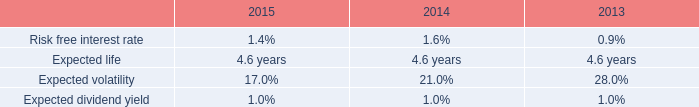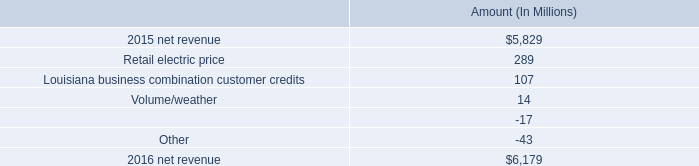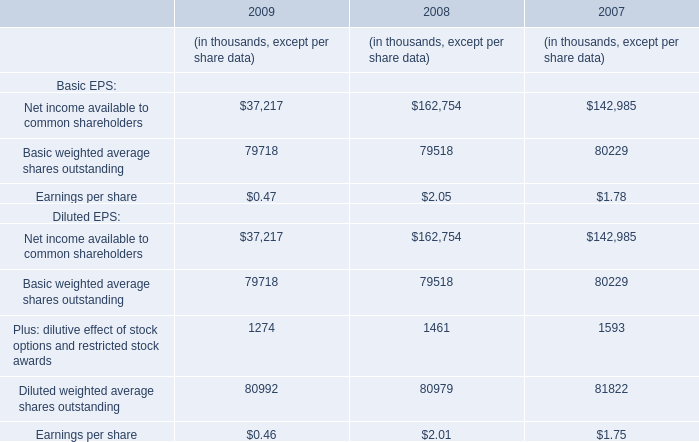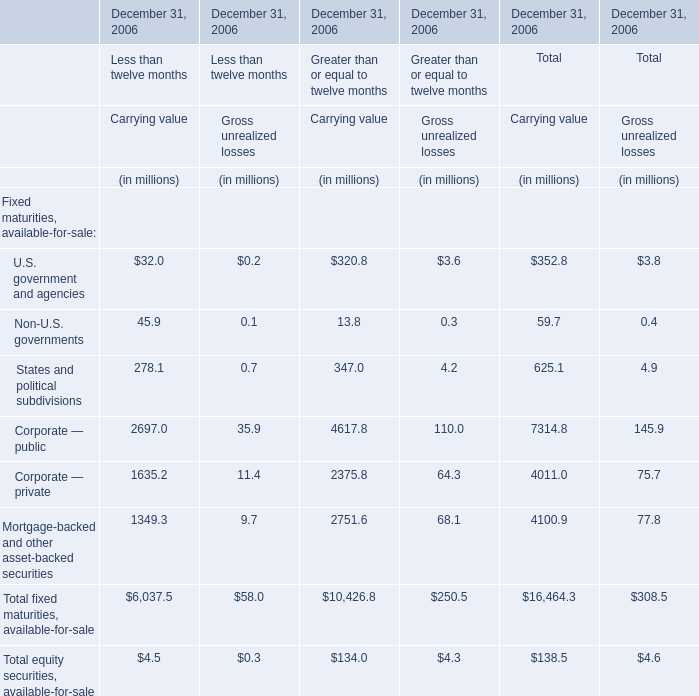Which section is U.S. government and agencies the highest for Less than twelve months? 
Answer: Carrying value. 